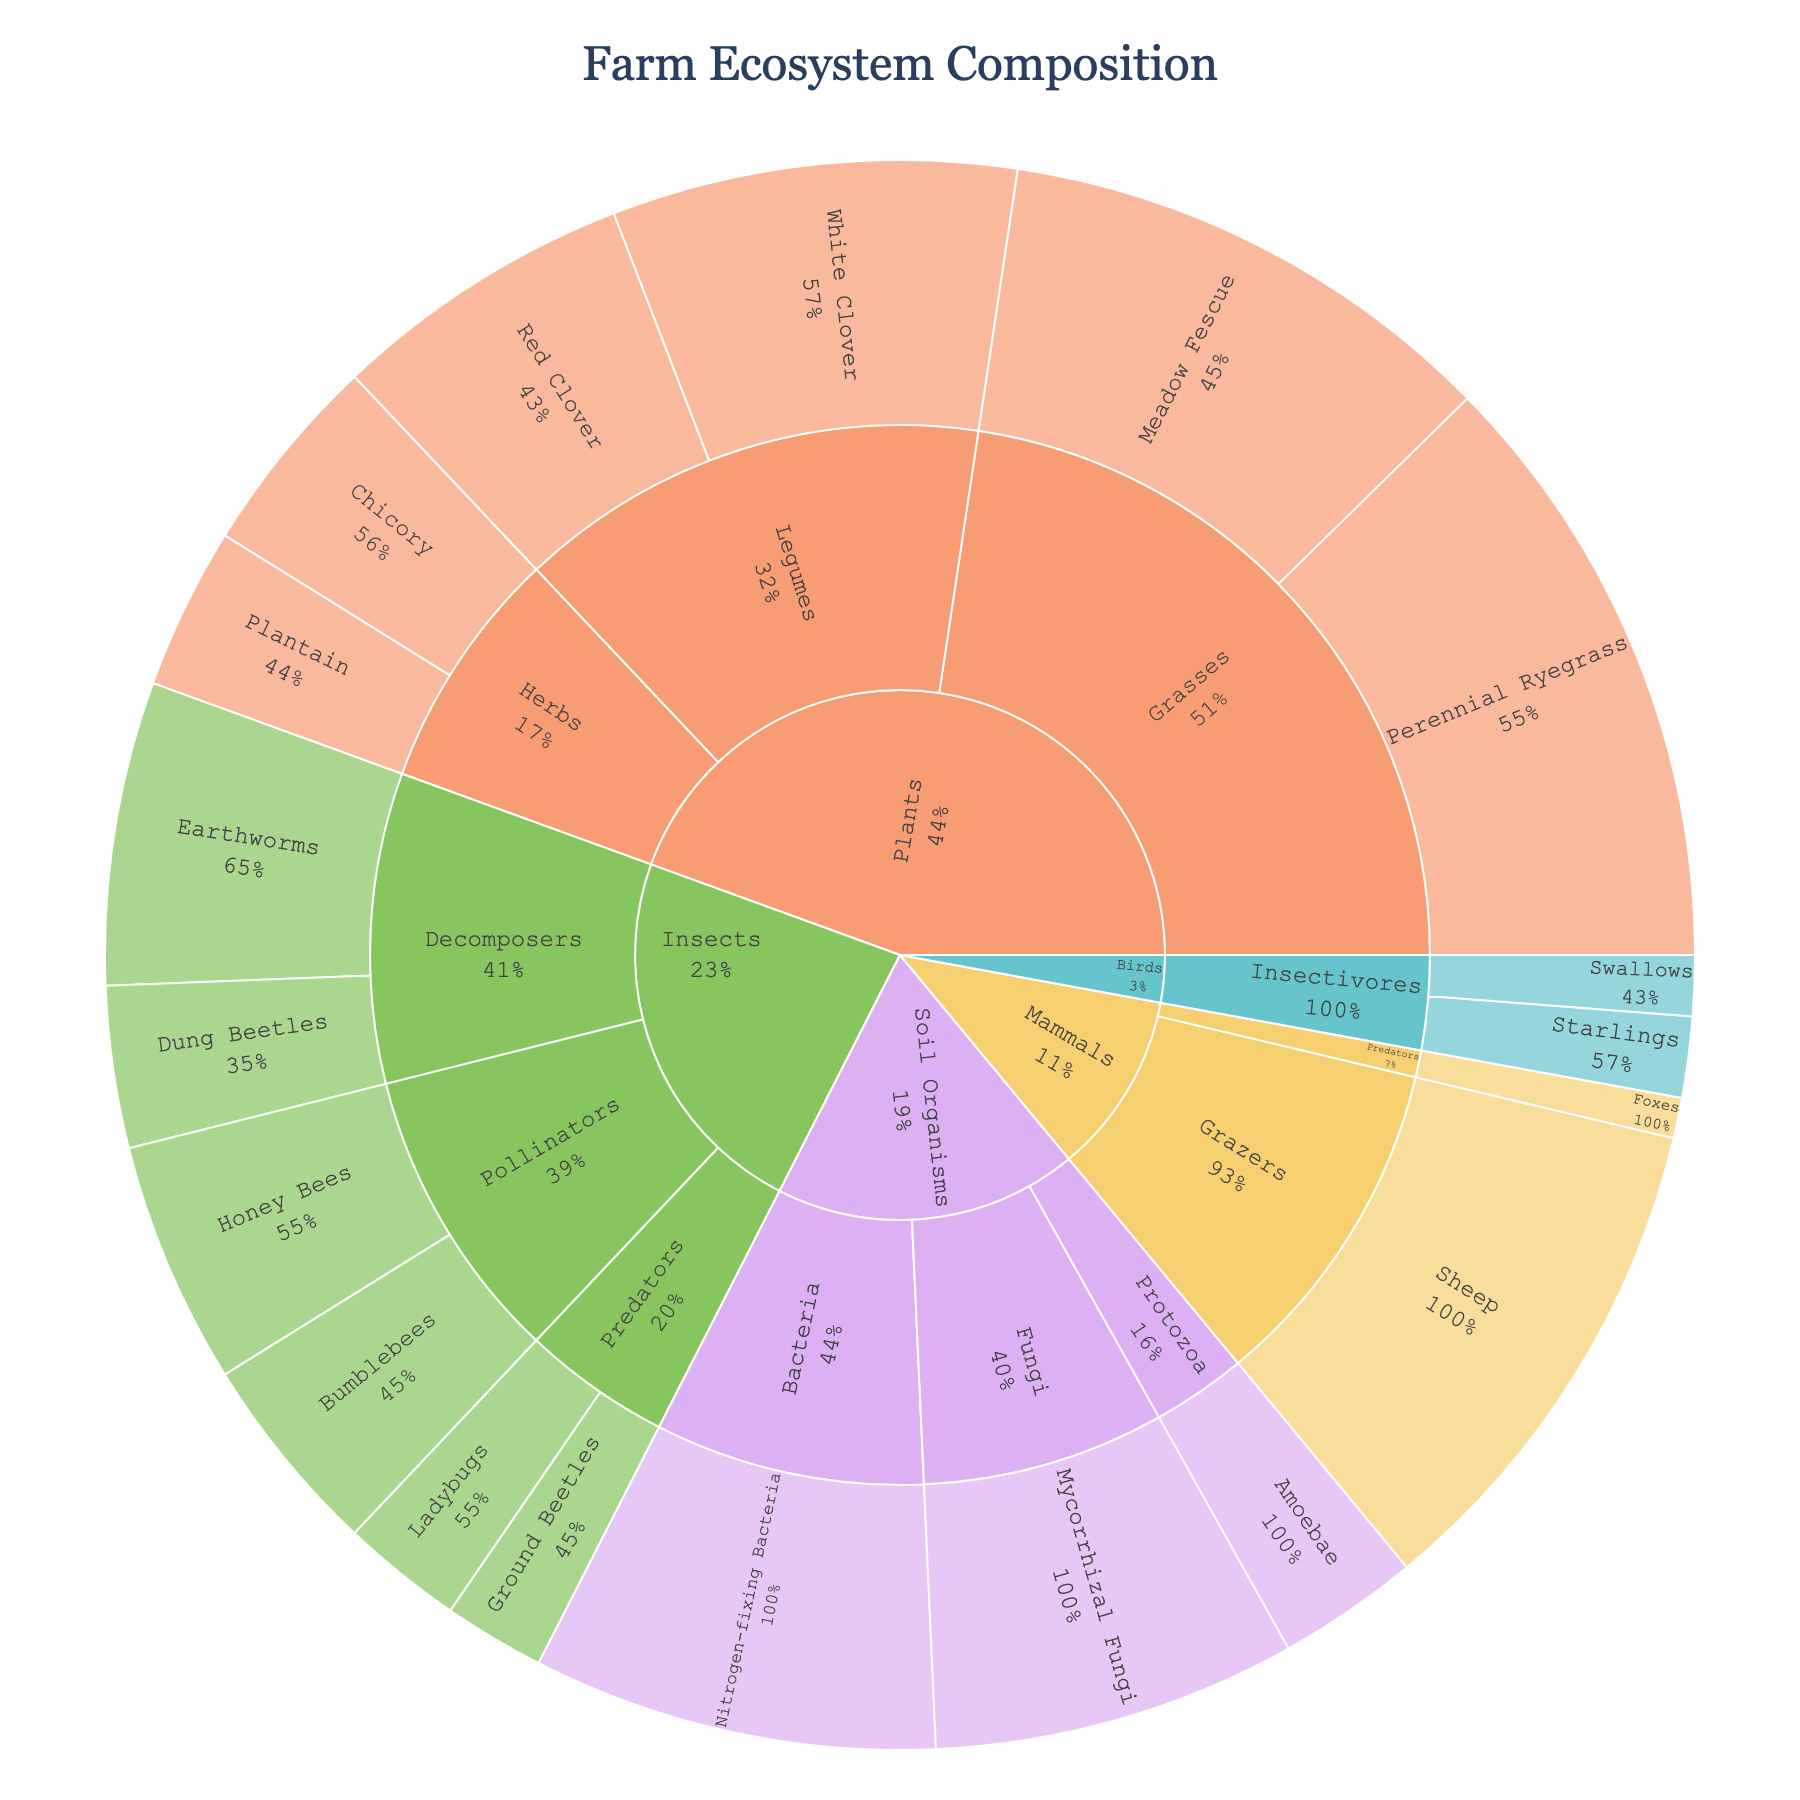What is the title of the Sunburst Plot? The title is placed prominently at the top of the plot, providing a summary of what the plot represents. It helps the viewer quickly understand the main topic of the visualization.
Answer: Farm Ecosystem Composition Which category has the highest total value? Look at the largest segment in the first outer ring of the sunburst plot. The size indicates the total value of each category.
Answer: Plants How many different subcategories of insects are shown? In the outer ring of the section labeled "Insects," count the distinct subcategories.
Answer: 3 What plant species has the highest value? Within the "Plants" category, find the largest segment among the subcategories to identify the species with the highest share.
Answer: Perennial Ryegrass What's the sum of values for the "Herbs" subcategory? Add the values of all items under the "Herbs" subcategory: Chicory (10) and Plantain (8). 10 + 8 = 18.
Answer: 18 Which subcategory within the Soil Organisms category has the smallest value? Look at the segments within the "Soil Organisms" category and compare their sizes; identify the smallest one.
Answer: Protozoa Are there more pollinators or decomposers among the insects? Sum the values of items under the "Pollinators" subcategory and compare them to the sum of values in the "Decomposers" subcategory. Pollinators: Honey Bees (12) + Bumblebees (10) = 22, Decomposers: Dung Beetles (8) + Earthworms (15) = 23.
Answer: Decomposers Which has a greater value: the total for "Bacteria" under Soil Organisms or "Grazers" under Mammals? Compare the values of the specified subcategories. Bacteria: 20, Grazers (Sheep): 25.
Answer: Grazers What percentage of the total Plants category does "Meadow Fescue" represent? Find the total value for the "Plants" category, then calculate the percentage for Meadow Fescue. Total Plants = 30 + 25 + 20 + 15 + 10 + 8 = 108. Percentage = (25 / 108) * 100 ≈ 23.15%.
Answer: Approximately 23.15% Which category includes "Foxes"? Locate "Foxes" in the sunburst plot and identify its parent category.
Answer: Mammals 